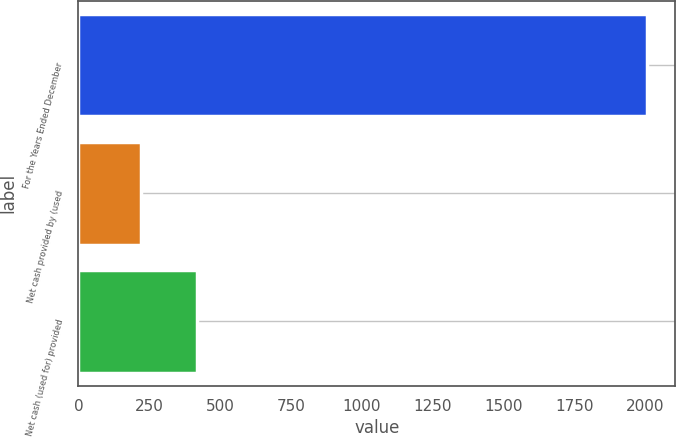Convert chart. <chart><loc_0><loc_0><loc_500><loc_500><bar_chart><fcel>For the Years Ended December<fcel>Net cash provided by (used<fcel>Net cash (used for) provided<nl><fcel>2006<fcel>220.4<fcel>418.8<nl></chart> 